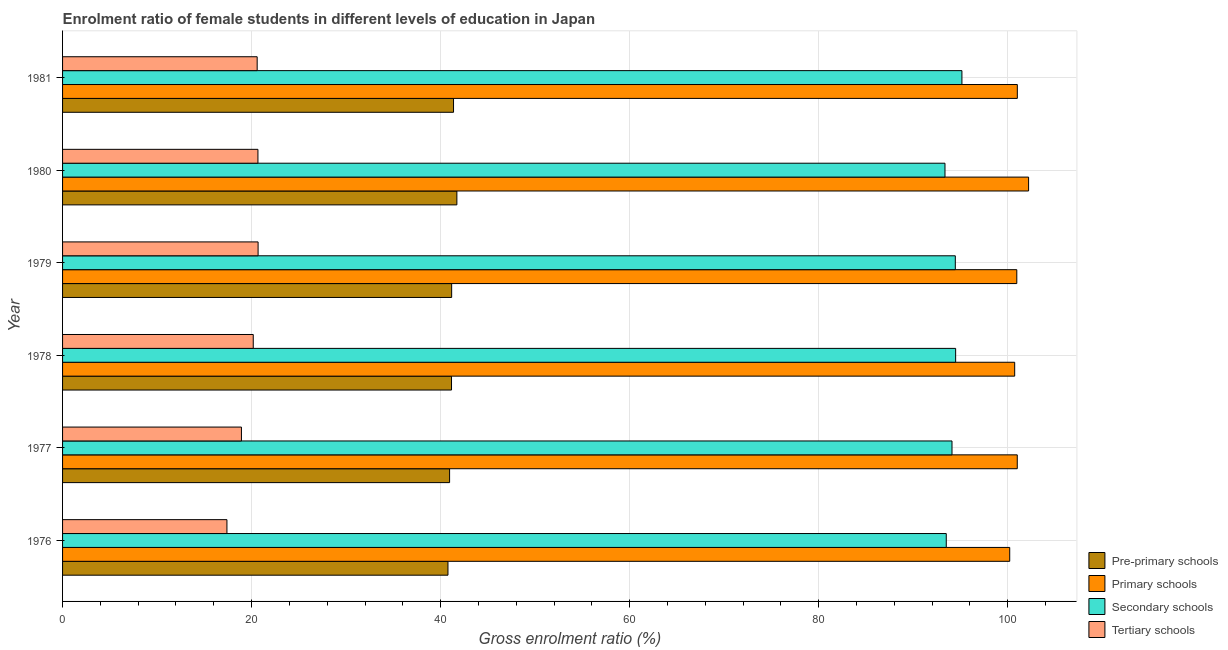How many groups of bars are there?
Keep it short and to the point. 6. Are the number of bars on each tick of the Y-axis equal?
Offer a terse response. Yes. How many bars are there on the 5th tick from the bottom?
Provide a succinct answer. 4. What is the label of the 3rd group of bars from the top?
Your answer should be compact. 1979. What is the gross enrolment ratio(male) in pre-primary schools in 1976?
Make the answer very short. 40.78. Across all years, what is the maximum gross enrolment ratio(male) in pre-primary schools?
Ensure brevity in your answer.  41.72. Across all years, what is the minimum gross enrolment ratio(male) in primary schools?
Keep it short and to the point. 100.21. In which year was the gross enrolment ratio(male) in pre-primary schools maximum?
Offer a terse response. 1980. In which year was the gross enrolment ratio(male) in primary schools minimum?
Ensure brevity in your answer.  1976. What is the total gross enrolment ratio(male) in primary schools in the graph?
Keep it short and to the point. 606.15. What is the difference between the gross enrolment ratio(male) in pre-primary schools in 1980 and that in 1981?
Ensure brevity in your answer.  0.35. What is the difference between the gross enrolment ratio(male) in primary schools in 1981 and the gross enrolment ratio(male) in secondary schools in 1980?
Your response must be concise. 7.66. What is the average gross enrolment ratio(male) in pre-primary schools per year?
Provide a succinct answer. 41.19. In the year 1977, what is the difference between the gross enrolment ratio(male) in pre-primary schools and gross enrolment ratio(male) in tertiary schools?
Offer a terse response. 22.02. What is the ratio of the gross enrolment ratio(male) in primary schools in 1979 to that in 1980?
Provide a short and direct response. 0.99. Is the gross enrolment ratio(male) in primary schools in 1979 less than that in 1980?
Your response must be concise. Yes. What is the difference between the highest and the second highest gross enrolment ratio(male) in pre-primary schools?
Your answer should be compact. 0.35. In how many years, is the gross enrolment ratio(male) in primary schools greater than the average gross enrolment ratio(male) in primary schools taken over all years?
Your answer should be very brief. 1. Is the sum of the gross enrolment ratio(male) in primary schools in 1976 and 1978 greater than the maximum gross enrolment ratio(male) in tertiary schools across all years?
Keep it short and to the point. Yes. What does the 3rd bar from the top in 1976 represents?
Your response must be concise. Primary schools. What does the 2nd bar from the bottom in 1980 represents?
Offer a very short reply. Primary schools. Is it the case that in every year, the sum of the gross enrolment ratio(male) in pre-primary schools and gross enrolment ratio(male) in primary schools is greater than the gross enrolment ratio(male) in secondary schools?
Keep it short and to the point. Yes. Are all the bars in the graph horizontal?
Your answer should be compact. Yes. How many years are there in the graph?
Provide a succinct answer. 6. What is the difference between two consecutive major ticks on the X-axis?
Provide a succinct answer. 20. Are the values on the major ticks of X-axis written in scientific E-notation?
Your answer should be compact. No. Does the graph contain grids?
Your response must be concise. Yes. How many legend labels are there?
Provide a succinct answer. 4. How are the legend labels stacked?
Your answer should be very brief. Vertical. What is the title of the graph?
Your answer should be very brief. Enrolment ratio of female students in different levels of education in Japan. What is the Gross enrolment ratio (%) of Pre-primary schools in 1976?
Your answer should be compact. 40.78. What is the Gross enrolment ratio (%) of Primary schools in 1976?
Offer a very short reply. 100.21. What is the Gross enrolment ratio (%) of Secondary schools in 1976?
Provide a short and direct response. 93.5. What is the Gross enrolment ratio (%) of Tertiary schools in 1976?
Your answer should be very brief. 17.39. What is the Gross enrolment ratio (%) in Pre-primary schools in 1977?
Keep it short and to the point. 40.95. What is the Gross enrolment ratio (%) of Primary schools in 1977?
Provide a succinct answer. 101.01. What is the Gross enrolment ratio (%) in Secondary schools in 1977?
Keep it short and to the point. 94.11. What is the Gross enrolment ratio (%) in Tertiary schools in 1977?
Offer a very short reply. 18.93. What is the Gross enrolment ratio (%) of Pre-primary schools in 1978?
Give a very brief answer. 41.15. What is the Gross enrolment ratio (%) of Primary schools in 1978?
Your answer should be very brief. 100.74. What is the Gross enrolment ratio (%) in Secondary schools in 1978?
Provide a short and direct response. 94.49. What is the Gross enrolment ratio (%) in Tertiary schools in 1978?
Keep it short and to the point. 20.17. What is the Gross enrolment ratio (%) of Pre-primary schools in 1979?
Provide a short and direct response. 41.17. What is the Gross enrolment ratio (%) in Primary schools in 1979?
Make the answer very short. 100.96. What is the Gross enrolment ratio (%) of Secondary schools in 1979?
Provide a succinct answer. 94.46. What is the Gross enrolment ratio (%) of Tertiary schools in 1979?
Provide a succinct answer. 20.69. What is the Gross enrolment ratio (%) of Pre-primary schools in 1980?
Give a very brief answer. 41.72. What is the Gross enrolment ratio (%) in Primary schools in 1980?
Your response must be concise. 102.21. What is the Gross enrolment ratio (%) in Secondary schools in 1980?
Your answer should be very brief. 93.36. What is the Gross enrolment ratio (%) of Tertiary schools in 1980?
Offer a terse response. 20.67. What is the Gross enrolment ratio (%) in Pre-primary schools in 1981?
Ensure brevity in your answer.  41.36. What is the Gross enrolment ratio (%) of Primary schools in 1981?
Make the answer very short. 101.02. What is the Gross enrolment ratio (%) of Secondary schools in 1981?
Ensure brevity in your answer.  95.16. What is the Gross enrolment ratio (%) in Tertiary schools in 1981?
Offer a very short reply. 20.59. Across all years, what is the maximum Gross enrolment ratio (%) in Pre-primary schools?
Make the answer very short. 41.72. Across all years, what is the maximum Gross enrolment ratio (%) in Primary schools?
Your answer should be compact. 102.21. Across all years, what is the maximum Gross enrolment ratio (%) in Secondary schools?
Your answer should be compact. 95.16. Across all years, what is the maximum Gross enrolment ratio (%) of Tertiary schools?
Keep it short and to the point. 20.69. Across all years, what is the minimum Gross enrolment ratio (%) of Pre-primary schools?
Your answer should be very brief. 40.78. Across all years, what is the minimum Gross enrolment ratio (%) in Primary schools?
Offer a very short reply. 100.21. Across all years, what is the minimum Gross enrolment ratio (%) of Secondary schools?
Give a very brief answer. 93.36. Across all years, what is the minimum Gross enrolment ratio (%) in Tertiary schools?
Your answer should be compact. 17.39. What is the total Gross enrolment ratio (%) of Pre-primary schools in the graph?
Give a very brief answer. 247.13. What is the total Gross enrolment ratio (%) of Primary schools in the graph?
Ensure brevity in your answer.  606.15. What is the total Gross enrolment ratio (%) of Secondary schools in the graph?
Your answer should be compact. 565.07. What is the total Gross enrolment ratio (%) of Tertiary schools in the graph?
Offer a terse response. 118.44. What is the difference between the Gross enrolment ratio (%) of Pre-primary schools in 1976 and that in 1977?
Provide a succinct answer. -0.17. What is the difference between the Gross enrolment ratio (%) in Primary schools in 1976 and that in 1977?
Your answer should be compact. -0.8. What is the difference between the Gross enrolment ratio (%) of Secondary schools in 1976 and that in 1977?
Offer a very short reply. -0.61. What is the difference between the Gross enrolment ratio (%) of Tertiary schools in 1976 and that in 1977?
Give a very brief answer. -1.54. What is the difference between the Gross enrolment ratio (%) in Pre-primary schools in 1976 and that in 1978?
Ensure brevity in your answer.  -0.37. What is the difference between the Gross enrolment ratio (%) in Primary schools in 1976 and that in 1978?
Offer a terse response. -0.53. What is the difference between the Gross enrolment ratio (%) of Secondary schools in 1976 and that in 1978?
Your answer should be compact. -0.99. What is the difference between the Gross enrolment ratio (%) of Tertiary schools in 1976 and that in 1978?
Offer a very short reply. -2.78. What is the difference between the Gross enrolment ratio (%) of Pre-primary schools in 1976 and that in 1979?
Offer a terse response. -0.39. What is the difference between the Gross enrolment ratio (%) of Primary schools in 1976 and that in 1979?
Provide a short and direct response. -0.75. What is the difference between the Gross enrolment ratio (%) of Secondary schools in 1976 and that in 1979?
Provide a short and direct response. -0.96. What is the difference between the Gross enrolment ratio (%) of Tertiary schools in 1976 and that in 1979?
Give a very brief answer. -3.3. What is the difference between the Gross enrolment ratio (%) in Pre-primary schools in 1976 and that in 1980?
Offer a very short reply. -0.94. What is the difference between the Gross enrolment ratio (%) of Primary schools in 1976 and that in 1980?
Give a very brief answer. -2. What is the difference between the Gross enrolment ratio (%) of Secondary schools in 1976 and that in 1980?
Offer a very short reply. 0.14. What is the difference between the Gross enrolment ratio (%) of Tertiary schools in 1976 and that in 1980?
Provide a succinct answer. -3.28. What is the difference between the Gross enrolment ratio (%) of Pre-primary schools in 1976 and that in 1981?
Your answer should be very brief. -0.59. What is the difference between the Gross enrolment ratio (%) in Primary schools in 1976 and that in 1981?
Keep it short and to the point. -0.81. What is the difference between the Gross enrolment ratio (%) in Secondary schools in 1976 and that in 1981?
Your response must be concise. -1.66. What is the difference between the Gross enrolment ratio (%) in Tertiary schools in 1976 and that in 1981?
Your answer should be compact. -3.2. What is the difference between the Gross enrolment ratio (%) of Pre-primary schools in 1977 and that in 1978?
Offer a terse response. -0.2. What is the difference between the Gross enrolment ratio (%) of Primary schools in 1977 and that in 1978?
Provide a succinct answer. 0.27. What is the difference between the Gross enrolment ratio (%) of Secondary schools in 1977 and that in 1978?
Your answer should be compact. -0.39. What is the difference between the Gross enrolment ratio (%) of Tertiary schools in 1977 and that in 1978?
Offer a very short reply. -1.25. What is the difference between the Gross enrolment ratio (%) in Pre-primary schools in 1977 and that in 1979?
Give a very brief answer. -0.22. What is the difference between the Gross enrolment ratio (%) of Primary schools in 1977 and that in 1979?
Make the answer very short. 0.05. What is the difference between the Gross enrolment ratio (%) in Secondary schools in 1977 and that in 1979?
Ensure brevity in your answer.  -0.35. What is the difference between the Gross enrolment ratio (%) of Tertiary schools in 1977 and that in 1979?
Provide a short and direct response. -1.76. What is the difference between the Gross enrolment ratio (%) of Pre-primary schools in 1977 and that in 1980?
Provide a short and direct response. -0.77. What is the difference between the Gross enrolment ratio (%) of Primary schools in 1977 and that in 1980?
Make the answer very short. -1.2. What is the difference between the Gross enrolment ratio (%) of Secondary schools in 1977 and that in 1980?
Make the answer very short. 0.74. What is the difference between the Gross enrolment ratio (%) of Tertiary schools in 1977 and that in 1980?
Offer a very short reply. -1.75. What is the difference between the Gross enrolment ratio (%) of Pre-primary schools in 1977 and that in 1981?
Offer a terse response. -0.42. What is the difference between the Gross enrolment ratio (%) in Primary schools in 1977 and that in 1981?
Give a very brief answer. -0.01. What is the difference between the Gross enrolment ratio (%) of Secondary schools in 1977 and that in 1981?
Give a very brief answer. -1.05. What is the difference between the Gross enrolment ratio (%) of Tertiary schools in 1977 and that in 1981?
Make the answer very short. -1.66. What is the difference between the Gross enrolment ratio (%) of Pre-primary schools in 1978 and that in 1979?
Your answer should be compact. -0.01. What is the difference between the Gross enrolment ratio (%) in Primary schools in 1978 and that in 1979?
Make the answer very short. -0.22. What is the difference between the Gross enrolment ratio (%) of Secondary schools in 1978 and that in 1979?
Keep it short and to the point. 0.03. What is the difference between the Gross enrolment ratio (%) of Tertiary schools in 1978 and that in 1979?
Keep it short and to the point. -0.51. What is the difference between the Gross enrolment ratio (%) of Pre-primary schools in 1978 and that in 1980?
Provide a succinct answer. -0.57. What is the difference between the Gross enrolment ratio (%) of Primary schools in 1978 and that in 1980?
Give a very brief answer. -1.47. What is the difference between the Gross enrolment ratio (%) of Secondary schools in 1978 and that in 1980?
Keep it short and to the point. 1.13. What is the difference between the Gross enrolment ratio (%) in Tertiary schools in 1978 and that in 1980?
Keep it short and to the point. -0.5. What is the difference between the Gross enrolment ratio (%) in Pre-primary schools in 1978 and that in 1981?
Your response must be concise. -0.21. What is the difference between the Gross enrolment ratio (%) of Primary schools in 1978 and that in 1981?
Make the answer very short. -0.28. What is the difference between the Gross enrolment ratio (%) in Secondary schools in 1978 and that in 1981?
Provide a succinct answer. -0.66. What is the difference between the Gross enrolment ratio (%) in Tertiary schools in 1978 and that in 1981?
Ensure brevity in your answer.  -0.42. What is the difference between the Gross enrolment ratio (%) in Pre-primary schools in 1979 and that in 1980?
Offer a terse response. -0.55. What is the difference between the Gross enrolment ratio (%) of Primary schools in 1979 and that in 1980?
Give a very brief answer. -1.25. What is the difference between the Gross enrolment ratio (%) in Secondary schools in 1979 and that in 1980?
Provide a short and direct response. 1.09. What is the difference between the Gross enrolment ratio (%) in Tertiary schools in 1979 and that in 1980?
Your response must be concise. 0.02. What is the difference between the Gross enrolment ratio (%) in Pre-primary schools in 1979 and that in 1981?
Provide a short and direct response. -0.2. What is the difference between the Gross enrolment ratio (%) in Primary schools in 1979 and that in 1981?
Ensure brevity in your answer.  -0.06. What is the difference between the Gross enrolment ratio (%) of Secondary schools in 1979 and that in 1981?
Provide a succinct answer. -0.7. What is the difference between the Gross enrolment ratio (%) of Tertiary schools in 1979 and that in 1981?
Provide a succinct answer. 0.1. What is the difference between the Gross enrolment ratio (%) in Pre-primary schools in 1980 and that in 1981?
Make the answer very short. 0.35. What is the difference between the Gross enrolment ratio (%) in Primary schools in 1980 and that in 1981?
Your answer should be very brief. 1.19. What is the difference between the Gross enrolment ratio (%) in Secondary schools in 1980 and that in 1981?
Offer a terse response. -1.79. What is the difference between the Gross enrolment ratio (%) of Tertiary schools in 1980 and that in 1981?
Ensure brevity in your answer.  0.08. What is the difference between the Gross enrolment ratio (%) in Pre-primary schools in 1976 and the Gross enrolment ratio (%) in Primary schools in 1977?
Your answer should be very brief. -60.23. What is the difference between the Gross enrolment ratio (%) of Pre-primary schools in 1976 and the Gross enrolment ratio (%) of Secondary schools in 1977?
Keep it short and to the point. -53.33. What is the difference between the Gross enrolment ratio (%) in Pre-primary schools in 1976 and the Gross enrolment ratio (%) in Tertiary schools in 1977?
Provide a succinct answer. 21.85. What is the difference between the Gross enrolment ratio (%) of Primary schools in 1976 and the Gross enrolment ratio (%) of Secondary schools in 1977?
Offer a terse response. 6.11. What is the difference between the Gross enrolment ratio (%) of Primary schools in 1976 and the Gross enrolment ratio (%) of Tertiary schools in 1977?
Your response must be concise. 81.29. What is the difference between the Gross enrolment ratio (%) of Secondary schools in 1976 and the Gross enrolment ratio (%) of Tertiary schools in 1977?
Keep it short and to the point. 74.57. What is the difference between the Gross enrolment ratio (%) in Pre-primary schools in 1976 and the Gross enrolment ratio (%) in Primary schools in 1978?
Offer a very short reply. -59.96. What is the difference between the Gross enrolment ratio (%) in Pre-primary schools in 1976 and the Gross enrolment ratio (%) in Secondary schools in 1978?
Offer a terse response. -53.71. What is the difference between the Gross enrolment ratio (%) in Pre-primary schools in 1976 and the Gross enrolment ratio (%) in Tertiary schools in 1978?
Make the answer very short. 20.6. What is the difference between the Gross enrolment ratio (%) of Primary schools in 1976 and the Gross enrolment ratio (%) of Secondary schools in 1978?
Give a very brief answer. 5.72. What is the difference between the Gross enrolment ratio (%) of Primary schools in 1976 and the Gross enrolment ratio (%) of Tertiary schools in 1978?
Provide a succinct answer. 80.04. What is the difference between the Gross enrolment ratio (%) in Secondary schools in 1976 and the Gross enrolment ratio (%) in Tertiary schools in 1978?
Your answer should be very brief. 73.32. What is the difference between the Gross enrolment ratio (%) in Pre-primary schools in 1976 and the Gross enrolment ratio (%) in Primary schools in 1979?
Make the answer very short. -60.18. What is the difference between the Gross enrolment ratio (%) of Pre-primary schools in 1976 and the Gross enrolment ratio (%) of Secondary schools in 1979?
Your answer should be compact. -53.68. What is the difference between the Gross enrolment ratio (%) in Pre-primary schools in 1976 and the Gross enrolment ratio (%) in Tertiary schools in 1979?
Your answer should be compact. 20.09. What is the difference between the Gross enrolment ratio (%) of Primary schools in 1976 and the Gross enrolment ratio (%) of Secondary schools in 1979?
Offer a very short reply. 5.75. What is the difference between the Gross enrolment ratio (%) in Primary schools in 1976 and the Gross enrolment ratio (%) in Tertiary schools in 1979?
Ensure brevity in your answer.  79.52. What is the difference between the Gross enrolment ratio (%) in Secondary schools in 1976 and the Gross enrolment ratio (%) in Tertiary schools in 1979?
Your response must be concise. 72.81. What is the difference between the Gross enrolment ratio (%) of Pre-primary schools in 1976 and the Gross enrolment ratio (%) of Primary schools in 1980?
Offer a terse response. -61.43. What is the difference between the Gross enrolment ratio (%) in Pre-primary schools in 1976 and the Gross enrolment ratio (%) in Secondary schools in 1980?
Make the answer very short. -52.58. What is the difference between the Gross enrolment ratio (%) in Pre-primary schools in 1976 and the Gross enrolment ratio (%) in Tertiary schools in 1980?
Your answer should be compact. 20.11. What is the difference between the Gross enrolment ratio (%) in Primary schools in 1976 and the Gross enrolment ratio (%) in Secondary schools in 1980?
Your answer should be compact. 6.85. What is the difference between the Gross enrolment ratio (%) in Primary schools in 1976 and the Gross enrolment ratio (%) in Tertiary schools in 1980?
Make the answer very short. 79.54. What is the difference between the Gross enrolment ratio (%) of Secondary schools in 1976 and the Gross enrolment ratio (%) of Tertiary schools in 1980?
Your answer should be very brief. 72.83. What is the difference between the Gross enrolment ratio (%) of Pre-primary schools in 1976 and the Gross enrolment ratio (%) of Primary schools in 1981?
Provide a short and direct response. -60.24. What is the difference between the Gross enrolment ratio (%) in Pre-primary schools in 1976 and the Gross enrolment ratio (%) in Secondary schools in 1981?
Ensure brevity in your answer.  -54.38. What is the difference between the Gross enrolment ratio (%) in Pre-primary schools in 1976 and the Gross enrolment ratio (%) in Tertiary schools in 1981?
Ensure brevity in your answer.  20.19. What is the difference between the Gross enrolment ratio (%) in Primary schools in 1976 and the Gross enrolment ratio (%) in Secondary schools in 1981?
Offer a terse response. 5.06. What is the difference between the Gross enrolment ratio (%) in Primary schools in 1976 and the Gross enrolment ratio (%) in Tertiary schools in 1981?
Provide a short and direct response. 79.62. What is the difference between the Gross enrolment ratio (%) of Secondary schools in 1976 and the Gross enrolment ratio (%) of Tertiary schools in 1981?
Provide a succinct answer. 72.91. What is the difference between the Gross enrolment ratio (%) of Pre-primary schools in 1977 and the Gross enrolment ratio (%) of Primary schools in 1978?
Give a very brief answer. -59.79. What is the difference between the Gross enrolment ratio (%) of Pre-primary schools in 1977 and the Gross enrolment ratio (%) of Secondary schools in 1978?
Offer a terse response. -53.54. What is the difference between the Gross enrolment ratio (%) in Pre-primary schools in 1977 and the Gross enrolment ratio (%) in Tertiary schools in 1978?
Offer a very short reply. 20.77. What is the difference between the Gross enrolment ratio (%) of Primary schools in 1977 and the Gross enrolment ratio (%) of Secondary schools in 1978?
Provide a short and direct response. 6.52. What is the difference between the Gross enrolment ratio (%) in Primary schools in 1977 and the Gross enrolment ratio (%) in Tertiary schools in 1978?
Provide a succinct answer. 80.84. What is the difference between the Gross enrolment ratio (%) in Secondary schools in 1977 and the Gross enrolment ratio (%) in Tertiary schools in 1978?
Offer a very short reply. 73.93. What is the difference between the Gross enrolment ratio (%) in Pre-primary schools in 1977 and the Gross enrolment ratio (%) in Primary schools in 1979?
Offer a terse response. -60.01. What is the difference between the Gross enrolment ratio (%) of Pre-primary schools in 1977 and the Gross enrolment ratio (%) of Secondary schools in 1979?
Offer a very short reply. -53.51. What is the difference between the Gross enrolment ratio (%) of Pre-primary schools in 1977 and the Gross enrolment ratio (%) of Tertiary schools in 1979?
Make the answer very short. 20.26. What is the difference between the Gross enrolment ratio (%) in Primary schools in 1977 and the Gross enrolment ratio (%) in Secondary schools in 1979?
Provide a short and direct response. 6.55. What is the difference between the Gross enrolment ratio (%) in Primary schools in 1977 and the Gross enrolment ratio (%) in Tertiary schools in 1979?
Your answer should be compact. 80.32. What is the difference between the Gross enrolment ratio (%) of Secondary schools in 1977 and the Gross enrolment ratio (%) of Tertiary schools in 1979?
Provide a short and direct response. 73.42. What is the difference between the Gross enrolment ratio (%) of Pre-primary schools in 1977 and the Gross enrolment ratio (%) of Primary schools in 1980?
Ensure brevity in your answer.  -61.26. What is the difference between the Gross enrolment ratio (%) in Pre-primary schools in 1977 and the Gross enrolment ratio (%) in Secondary schools in 1980?
Your answer should be very brief. -52.41. What is the difference between the Gross enrolment ratio (%) of Pre-primary schools in 1977 and the Gross enrolment ratio (%) of Tertiary schools in 1980?
Offer a very short reply. 20.28. What is the difference between the Gross enrolment ratio (%) of Primary schools in 1977 and the Gross enrolment ratio (%) of Secondary schools in 1980?
Your answer should be very brief. 7.65. What is the difference between the Gross enrolment ratio (%) in Primary schools in 1977 and the Gross enrolment ratio (%) in Tertiary schools in 1980?
Your response must be concise. 80.34. What is the difference between the Gross enrolment ratio (%) in Secondary schools in 1977 and the Gross enrolment ratio (%) in Tertiary schools in 1980?
Provide a succinct answer. 73.43. What is the difference between the Gross enrolment ratio (%) in Pre-primary schools in 1977 and the Gross enrolment ratio (%) in Primary schools in 1981?
Make the answer very short. -60.07. What is the difference between the Gross enrolment ratio (%) in Pre-primary schools in 1977 and the Gross enrolment ratio (%) in Secondary schools in 1981?
Make the answer very short. -54.21. What is the difference between the Gross enrolment ratio (%) in Pre-primary schools in 1977 and the Gross enrolment ratio (%) in Tertiary schools in 1981?
Offer a terse response. 20.36. What is the difference between the Gross enrolment ratio (%) of Primary schools in 1977 and the Gross enrolment ratio (%) of Secondary schools in 1981?
Make the answer very short. 5.85. What is the difference between the Gross enrolment ratio (%) of Primary schools in 1977 and the Gross enrolment ratio (%) of Tertiary schools in 1981?
Provide a short and direct response. 80.42. What is the difference between the Gross enrolment ratio (%) in Secondary schools in 1977 and the Gross enrolment ratio (%) in Tertiary schools in 1981?
Give a very brief answer. 73.52. What is the difference between the Gross enrolment ratio (%) in Pre-primary schools in 1978 and the Gross enrolment ratio (%) in Primary schools in 1979?
Your response must be concise. -59.81. What is the difference between the Gross enrolment ratio (%) of Pre-primary schools in 1978 and the Gross enrolment ratio (%) of Secondary schools in 1979?
Provide a short and direct response. -53.3. What is the difference between the Gross enrolment ratio (%) in Pre-primary schools in 1978 and the Gross enrolment ratio (%) in Tertiary schools in 1979?
Your answer should be very brief. 20.46. What is the difference between the Gross enrolment ratio (%) of Primary schools in 1978 and the Gross enrolment ratio (%) of Secondary schools in 1979?
Keep it short and to the point. 6.28. What is the difference between the Gross enrolment ratio (%) in Primary schools in 1978 and the Gross enrolment ratio (%) in Tertiary schools in 1979?
Provide a short and direct response. 80.05. What is the difference between the Gross enrolment ratio (%) of Secondary schools in 1978 and the Gross enrolment ratio (%) of Tertiary schools in 1979?
Your answer should be very brief. 73.8. What is the difference between the Gross enrolment ratio (%) in Pre-primary schools in 1978 and the Gross enrolment ratio (%) in Primary schools in 1980?
Ensure brevity in your answer.  -61.06. What is the difference between the Gross enrolment ratio (%) in Pre-primary schools in 1978 and the Gross enrolment ratio (%) in Secondary schools in 1980?
Offer a terse response. -52.21. What is the difference between the Gross enrolment ratio (%) of Pre-primary schools in 1978 and the Gross enrolment ratio (%) of Tertiary schools in 1980?
Provide a short and direct response. 20.48. What is the difference between the Gross enrolment ratio (%) in Primary schools in 1978 and the Gross enrolment ratio (%) in Secondary schools in 1980?
Provide a short and direct response. 7.38. What is the difference between the Gross enrolment ratio (%) of Primary schools in 1978 and the Gross enrolment ratio (%) of Tertiary schools in 1980?
Offer a very short reply. 80.07. What is the difference between the Gross enrolment ratio (%) in Secondary schools in 1978 and the Gross enrolment ratio (%) in Tertiary schools in 1980?
Provide a short and direct response. 73.82. What is the difference between the Gross enrolment ratio (%) of Pre-primary schools in 1978 and the Gross enrolment ratio (%) of Primary schools in 1981?
Keep it short and to the point. -59.87. What is the difference between the Gross enrolment ratio (%) in Pre-primary schools in 1978 and the Gross enrolment ratio (%) in Secondary schools in 1981?
Your response must be concise. -54. What is the difference between the Gross enrolment ratio (%) of Pre-primary schools in 1978 and the Gross enrolment ratio (%) of Tertiary schools in 1981?
Your response must be concise. 20.56. What is the difference between the Gross enrolment ratio (%) of Primary schools in 1978 and the Gross enrolment ratio (%) of Secondary schools in 1981?
Your answer should be compact. 5.58. What is the difference between the Gross enrolment ratio (%) of Primary schools in 1978 and the Gross enrolment ratio (%) of Tertiary schools in 1981?
Your answer should be compact. 80.15. What is the difference between the Gross enrolment ratio (%) of Secondary schools in 1978 and the Gross enrolment ratio (%) of Tertiary schools in 1981?
Make the answer very short. 73.9. What is the difference between the Gross enrolment ratio (%) of Pre-primary schools in 1979 and the Gross enrolment ratio (%) of Primary schools in 1980?
Your answer should be very brief. -61.04. What is the difference between the Gross enrolment ratio (%) of Pre-primary schools in 1979 and the Gross enrolment ratio (%) of Secondary schools in 1980?
Keep it short and to the point. -52.2. What is the difference between the Gross enrolment ratio (%) of Pre-primary schools in 1979 and the Gross enrolment ratio (%) of Tertiary schools in 1980?
Your answer should be very brief. 20.5. What is the difference between the Gross enrolment ratio (%) in Primary schools in 1979 and the Gross enrolment ratio (%) in Secondary schools in 1980?
Your answer should be compact. 7.6. What is the difference between the Gross enrolment ratio (%) of Primary schools in 1979 and the Gross enrolment ratio (%) of Tertiary schools in 1980?
Keep it short and to the point. 80.29. What is the difference between the Gross enrolment ratio (%) in Secondary schools in 1979 and the Gross enrolment ratio (%) in Tertiary schools in 1980?
Make the answer very short. 73.79. What is the difference between the Gross enrolment ratio (%) in Pre-primary schools in 1979 and the Gross enrolment ratio (%) in Primary schools in 1981?
Ensure brevity in your answer.  -59.85. What is the difference between the Gross enrolment ratio (%) of Pre-primary schools in 1979 and the Gross enrolment ratio (%) of Secondary schools in 1981?
Provide a short and direct response. -53.99. What is the difference between the Gross enrolment ratio (%) of Pre-primary schools in 1979 and the Gross enrolment ratio (%) of Tertiary schools in 1981?
Offer a terse response. 20.58. What is the difference between the Gross enrolment ratio (%) of Primary schools in 1979 and the Gross enrolment ratio (%) of Secondary schools in 1981?
Your response must be concise. 5.81. What is the difference between the Gross enrolment ratio (%) of Primary schools in 1979 and the Gross enrolment ratio (%) of Tertiary schools in 1981?
Your answer should be very brief. 80.37. What is the difference between the Gross enrolment ratio (%) in Secondary schools in 1979 and the Gross enrolment ratio (%) in Tertiary schools in 1981?
Keep it short and to the point. 73.87. What is the difference between the Gross enrolment ratio (%) in Pre-primary schools in 1980 and the Gross enrolment ratio (%) in Primary schools in 1981?
Your answer should be compact. -59.3. What is the difference between the Gross enrolment ratio (%) in Pre-primary schools in 1980 and the Gross enrolment ratio (%) in Secondary schools in 1981?
Provide a short and direct response. -53.44. What is the difference between the Gross enrolment ratio (%) in Pre-primary schools in 1980 and the Gross enrolment ratio (%) in Tertiary schools in 1981?
Your answer should be very brief. 21.13. What is the difference between the Gross enrolment ratio (%) of Primary schools in 1980 and the Gross enrolment ratio (%) of Secondary schools in 1981?
Give a very brief answer. 7.05. What is the difference between the Gross enrolment ratio (%) of Primary schools in 1980 and the Gross enrolment ratio (%) of Tertiary schools in 1981?
Ensure brevity in your answer.  81.62. What is the difference between the Gross enrolment ratio (%) in Secondary schools in 1980 and the Gross enrolment ratio (%) in Tertiary schools in 1981?
Give a very brief answer. 72.77. What is the average Gross enrolment ratio (%) of Pre-primary schools per year?
Your answer should be very brief. 41.19. What is the average Gross enrolment ratio (%) of Primary schools per year?
Give a very brief answer. 101.03. What is the average Gross enrolment ratio (%) of Secondary schools per year?
Keep it short and to the point. 94.18. What is the average Gross enrolment ratio (%) in Tertiary schools per year?
Your answer should be very brief. 19.74. In the year 1976, what is the difference between the Gross enrolment ratio (%) of Pre-primary schools and Gross enrolment ratio (%) of Primary schools?
Keep it short and to the point. -59.43. In the year 1976, what is the difference between the Gross enrolment ratio (%) of Pre-primary schools and Gross enrolment ratio (%) of Secondary schools?
Your answer should be very brief. -52.72. In the year 1976, what is the difference between the Gross enrolment ratio (%) in Pre-primary schools and Gross enrolment ratio (%) in Tertiary schools?
Your response must be concise. 23.39. In the year 1976, what is the difference between the Gross enrolment ratio (%) in Primary schools and Gross enrolment ratio (%) in Secondary schools?
Your answer should be compact. 6.71. In the year 1976, what is the difference between the Gross enrolment ratio (%) of Primary schools and Gross enrolment ratio (%) of Tertiary schools?
Provide a succinct answer. 82.82. In the year 1976, what is the difference between the Gross enrolment ratio (%) of Secondary schools and Gross enrolment ratio (%) of Tertiary schools?
Offer a very short reply. 76.11. In the year 1977, what is the difference between the Gross enrolment ratio (%) in Pre-primary schools and Gross enrolment ratio (%) in Primary schools?
Your answer should be compact. -60.06. In the year 1977, what is the difference between the Gross enrolment ratio (%) in Pre-primary schools and Gross enrolment ratio (%) in Secondary schools?
Offer a very short reply. -53.16. In the year 1977, what is the difference between the Gross enrolment ratio (%) of Pre-primary schools and Gross enrolment ratio (%) of Tertiary schools?
Make the answer very short. 22.02. In the year 1977, what is the difference between the Gross enrolment ratio (%) of Primary schools and Gross enrolment ratio (%) of Secondary schools?
Your answer should be very brief. 6.91. In the year 1977, what is the difference between the Gross enrolment ratio (%) in Primary schools and Gross enrolment ratio (%) in Tertiary schools?
Provide a short and direct response. 82.08. In the year 1977, what is the difference between the Gross enrolment ratio (%) in Secondary schools and Gross enrolment ratio (%) in Tertiary schools?
Your response must be concise. 75.18. In the year 1978, what is the difference between the Gross enrolment ratio (%) of Pre-primary schools and Gross enrolment ratio (%) of Primary schools?
Give a very brief answer. -59.59. In the year 1978, what is the difference between the Gross enrolment ratio (%) in Pre-primary schools and Gross enrolment ratio (%) in Secondary schools?
Offer a very short reply. -53.34. In the year 1978, what is the difference between the Gross enrolment ratio (%) of Pre-primary schools and Gross enrolment ratio (%) of Tertiary schools?
Your answer should be very brief. 20.98. In the year 1978, what is the difference between the Gross enrolment ratio (%) of Primary schools and Gross enrolment ratio (%) of Secondary schools?
Make the answer very short. 6.25. In the year 1978, what is the difference between the Gross enrolment ratio (%) in Primary schools and Gross enrolment ratio (%) in Tertiary schools?
Keep it short and to the point. 80.56. In the year 1978, what is the difference between the Gross enrolment ratio (%) of Secondary schools and Gross enrolment ratio (%) of Tertiary schools?
Provide a short and direct response. 74.32. In the year 1979, what is the difference between the Gross enrolment ratio (%) of Pre-primary schools and Gross enrolment ratio (%) of Primary schools?
Ensure brevity in your answer.  -59.79. In the year 1979, what is the difference between the Gross enrolment ratio (%) in Pre-primary schools and Gross enrolment ratio (%) in Secondary schools?
Provide a short and direct response. -53.29. In the year 1979, what is the difference between the Gross enrolment ratio (%) of Pre-primary schools and Gross enrolment ratio (%) of Tertiary schools?
Ensure brevity in your answer.  20.48. In the year 1979, what is the difference between the Gross enrolment ratio (%) of Primary schools and Gross enrolment ratio (%) of Secondary schools?
Ensure brevity in your answer.  6.5. In the year 1979, what is the difference between the Gross enrolment ratio (%) in Primary schools and Gross enrolment ratio (%) in Tertiary schools?
Your answer should be compact. 80.27. In the year 1979, what is the difference between the Gross enrolment ratio (%) of Secondary schools and Gross enrolment ratio (%) of Tertiary schools?
Provide a succinct answer. 73.77. In the year 1980, what is the difference between the Gross enrolment ratio (%) of Pre-primary schools and Gross enrolment ratio (%) of Primary schools?
Your response must be concise. -60.49. In the year 1980, what is the difference between the Gross enrolment ratio (%) in Pre-primary schools and Gross enrolment ratio (%) in Secondary schools?
Give a very brief answer. -51.64. In the year 1980, what is the difference between the Gross enrolment ratio (%) in Pre-primary schools and Gross enrolment ratio (%) in Tertiary schools?
Offer a terse response. 21.05. In the year 1980, what is the difference between the Gross enrolment ratio (%) of Primary schools and Gross enrolment ratio (%) of Secondary schools?
Your answer should be compact. 8.85. In the year 1980, what is the difference between the Gross enrolment ratio (%) of Primary schools and Gross enrolment ratio (%) of Tertiary schools?
Offer a very short reply. 81.54. In the year 1980, what is the difference between the Gross enrolment ratio (%) in Secondary schools and Gross enrolment ratio (%) in Tertiary schools?
Offer a terse response. 72.69. In the year 1981, what is the difference between the Gross enrolment ratio (%) in Pre-primary schools and Gross enrolment ratio (%) in Primary schools?
Ensure brevity in your answer.  -59.65. In the year 1981, what is the difference between the Gross enrolment ratio (%) in Pre-primary schools and Gross enrolment ratio (%) in Secondary schools?
Your answer should be compact. -53.79. In the year 1981, what is the difference between the Gross enrolment ratio (%) in Pre-primary schools and Gross enrolment ratio (%) in Tertiary schools?
Provide a succinct answer. 20.78. In the year 1981, what is the difference between the Gross enrolment ratio (%) in Primary schools and Gross enrolment ratio (%) in Secondary schools?
Provide a short and direct response. 5.86. In the year 1981, what is the difference between the Gross enrolment ratio (%) in Primary schools and Gross enrolment ratio (%) in Tertiary schools?
Offer a terse response. 80.43. In the year 1981, what is the difference between the Gross enrolment ratio (%) of Secondary schools and Gross enrolment ratio (%) of Tertiary schools?
Provide a succinct answer. 74.57. What is the ratio of the Gross enrolment ratio (%) of Primary schools in 1976 to that in 1977?
Provide a succinct answer. 0.99. What is the ratio of the Gross enrolment ratio (%) in Secondary schools in 1976 to that in 1977?
Offer a very short reply. 0.99. What is the ratio of the Gross enrolment ratio (%) of Tertiary schools in 1976 to that in 1977?
Make the answer very short. 0.92. What is the ratio of the Gross enrolment ratio (%) in Pre-primary schools in 1976 to that in 1978?
Provide a succinct answer. 0.99. What is the ratio of the Gross enrolment ratio (%) of Tertiary schools in 1976 to that in 1978?
Make the answer very short. 0.86. What is the ratio of the Gross enrolment ratio (%) of Pre-primary schools in 1976 to that in 1979?
Your response must be concise. 0.99. What is the ratio of the Gross enrolment ratio (%) of Primary schools in 1976 to that in 1979?
Make the answer very short. 0.99. What is the ratio of the Gross enrolment ratio (%) in Secondary schools in 1976 to that in 1979?
Provide a succinct answer. 0.99. What is the ratio of the Gross enrolment ratio (%) of Tertiary schools in 1976 to that in 1979?
Offer a very short reply. 0.84. What is the ratio of the Gross enrolment ratio (%) in Pre-primary schools in 1976 to that in 1980?
Make the answer very short. 0.98. What is the ratio of the Gross enrolment ratio (%) of Primary schools in 1976 to that in 1980?
Offer a terse response. 0.98. What is the ratio of the Gross enrolment ratio (%) of Tertiary schools in 1976 to that in 1980?
Provide a short and direct response. 0.84. What is the ratio of the Gross enrolment ratio (%) in Pre-primary schools in 1976 to that in 1981?
Your answer should be compact. 0.99. What is the ratio of the Gross enrolment ratio (%) in Secondary schools in 1976 to that in 1981?
Make the answer very short. 0.98. What is the ratio of the Gross enrolment ratio (%) of Tertiary schools in 1976 to that in 1981?
Your answer should be compact. 0.84. What is the ratio of the Gross enrolment ratio (%) in Tertiary schools in 1977 to that in 1978?
Keep it short and to the point. 0.94. What is the ratio of the Gross enrolment ratio (%) of Pre-primary schools in 1977 to that in 1979?
Your response must be concise. 0.99. What is the ratio of the Gross enrolment ratio (%) of Secondary schools in 1977 to that in 1979?
Your response must be concise. 1. What is the ratio of the Gross enrolment ratio (%) of Tertiary schools in 1977 to that in 1979?
Your answer should be compact. 0.91. What is the ratio of the Gross enrolment ratio (%) in Pre-primary schools in 1977 to that in 1980?
Ensure brevity in your answer.  0.98. What is the ratio of the Gross enrolment ratio (%) of Primary schools in 1977 to that in 1980?
Your response must be concise. 0.99. What is the ratio of the Gross enrolment ratio (%) in Tertiary schools in 1977 to that in 1980?
Provide a succinct answer. 0.92. What is the ratio of the Gross enrolment ratio (%) of Pre-primary schools in 1977 to that in 1981?
Keep it short and to the point. 0.99. What is the ratio of the Gross enrolment ratio (%) in Tertiary schools in 1977 to that in 1981?
Give a very brief answer. 0.92. What is the ratio of the Gross enrolment ratio (%) of Tertiary schools in 1978 to that in 1979?
Offer a terse response. 0.98. What is the ratio of the Gross enrolment ratio (%) of Pre-primary schools in 1978 to that in 1980?
Your response must be concise. 0.99. What is the ratio of the Gross enrolment ratio (%) in Primary schools in 1978 to that in 1980?
Your response must be concise. 0.99. What is the ratio of the Gross enrolment ratio (%) in Secondary schools in 1978 to that in 1980?
Your response must be concise. 1.01. What is the ratio of the Gross enrolment ratio (%) of Secondary schools in 1978 to that in 1981?
Offer a terse response. 0.99. What is the ratio of the Gross enrolment ratio (%) in Tertiary schools in 1978 to that in 1981?
Your answer should be compact. 0.98. What is the ratio of the Gross enrolment ratio (%) in Pre-primary schools in 1979 to that in 1980?
Your response must be concise. 0.99. What is the ratio of the Gross enrolment ratio (%) in Secondary schools in 1979 to that in 1980?
Your answer should be compact. 1.01. What is the ratio of the Gross enrolment ratio (%) of Pre-primary schools in 1979 to that in 1981?
Provide a succinct answer. 1. What is the ratio of the Gross enrolment ratio (%) in Secondary schools in 1979 to that in 1981?
Give a very brief answer. 0.99. What is the ratio of the Gross enrolment ratio (%) of Pre-primary schools in 1980 to that in 1981?
Give a very brief answer. 1.01. What is the ratio of the Gross enrolment ratio (%) in Primary schools in 1980 to that in 1981?
Make the answer very short. 1.01. What is the ratio of the Gross enrolment ratio (%) in Secondary schools in 1980 to that in 1981?
Your answer should be very brief. 0.98. What is the ratio of the Gross enrolment ratio (%) in Tertiary schools in 1980 to that in 1981?
Your answer should be very brief. 1. What is the difference between the highest and the second highest Gross enrolment ratio (%) in Pre-primary schools?
Your answer should be very brief. 0.35. What is the difference between the highest and the second highest Gross enrolment ratio (%) of Primary schools?
Offer a terse response. 1.19. What is the difference between the highest and the second highest Gross enrolment ratio (%) of Secondary schools?
Offer a terse response. 0.66. What is the difference between the highest and the second highest Gross enrolment ratio (%) of Tertiary schools?
Provide a short and direct response. 0.02. What is the difference between the highest and the lowest Gross enrolment ratio (%) of Pre-primary schools?
Your answer should be compact. 0.94. What is the difference between the highest and the lowest Gross enrolment ratio (%) in Primary schools?
Offer a terse response. 2. What is the difference between the highest and the lowest Gross enrolment ratio (%) in Secondary schools?
Provide a succinct answer. 1.79. What is the difference between the highest and the lowest Gross enrolment ratio (%) of Tertiary schools?
Make the answer very short. 3.3. 